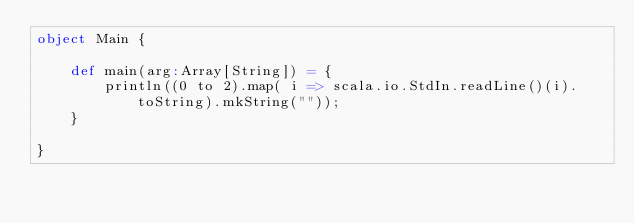Convert code to text. <code><loc_0><loc_0><loc_500><loc_500><_Scala_>object Main {

	def main(arg:Array[String]) = {
		println((0 to 2).map( i => scala.io.StdIn.readLine()(i).toString).mkString(""));
	}

}</code> 